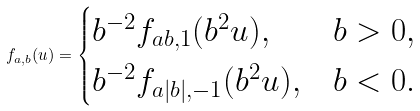Convert formula to latex. <formula><loc_0><loc_0><loc_500><loc_500>f _ { a , b } ( u ) = \begin{cases} b ^ { - 2 } f _ { a b , 1 } ( b ^ { 2 } u ) , & b > 0 , \\ b ^ { - 2 } f _ { a | b | , - 1 } ( b ^ { 2 } u ) , & b < 0 . \end{cases}</formula> 